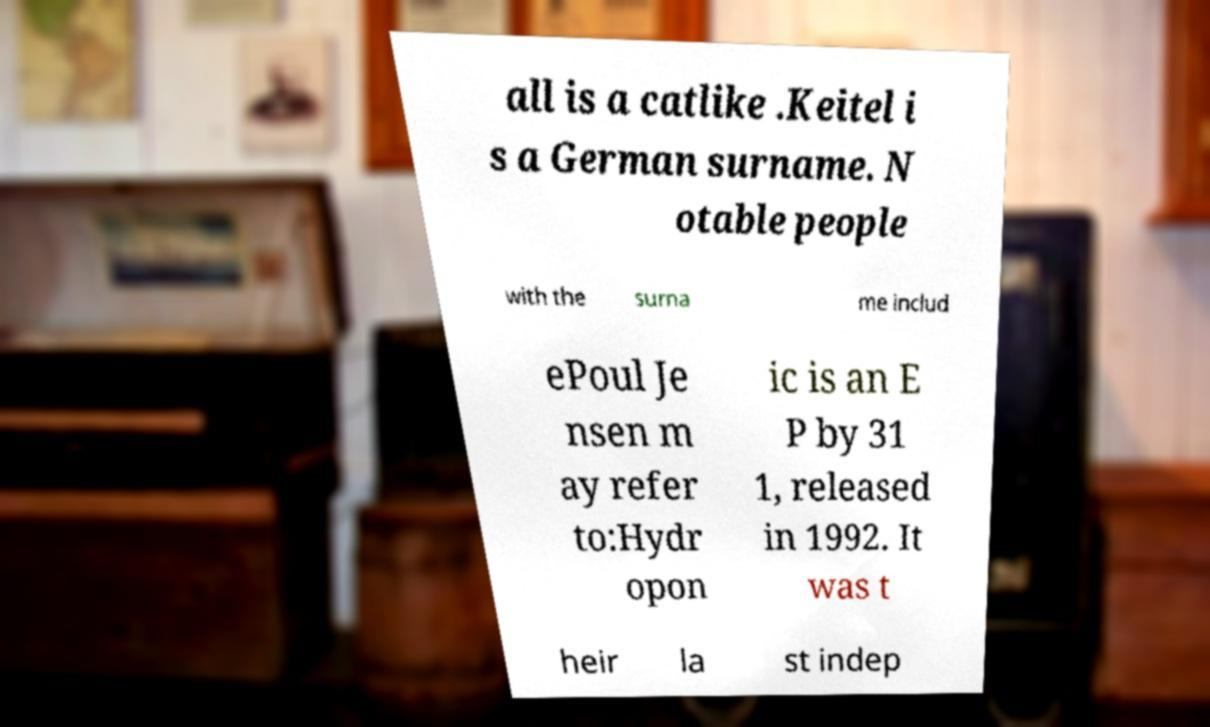Can you read and provide the text displayed in the image?This photo seems to have some interesting text. Can you extract and type it out for me? all is a catlike .Keitel i s a German surname. N otable people with the surna me includ ePoul Je nsen m ay refer to:Hydr opon ic is an E P by 31 1, released in 1992. It was t heir la st indep 